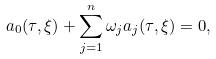Convert formula to latex. <formula><loc_0><loc_0><loc_500><loc_500>a _ { 0 } ( \tau , \xi ) + \sum _ { j = 1 } ^ { n } \omega _ { j } a _ { j } ( \tau , \xi ) = 0 ,</formula> 